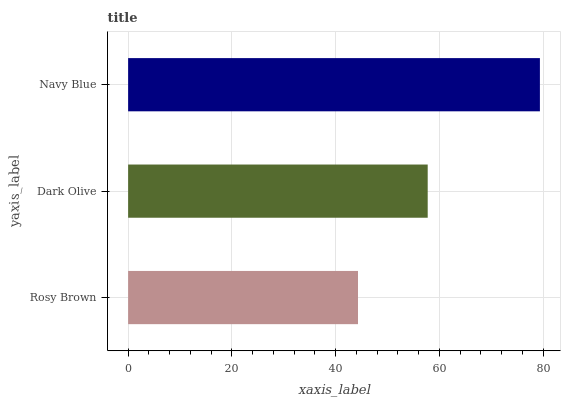Is Rosy Brown the minimum?
Answer yes or no. Yes. Is Navy Blue the maximum?
Answer yes or no. Yes. Is Dark Olive the minimum?
Answer yes or no. No. Is Dark Olive the maximum?
Answer yes or no. No. Is Dark Olive greater than Rosy Brown?
Answer yes or no. Yes. Is Rosy Brown less than Dark Olive?
Answer yes or no. Yes. Is Rosy Brown greater than Dark Olive?
Answer yes or no. No. Is Dark Olive less than Rosy Brown?
Answer yes or no. No. Is Dark Olive the high median?
Answer yes or no. Yes. Is Dark Olive the low median?
Answer yes or no. Yes. Is Navy Blue the high median?
Answer yes or no. No. Is Navy Blue the low median?
Answer yes or no. No. 